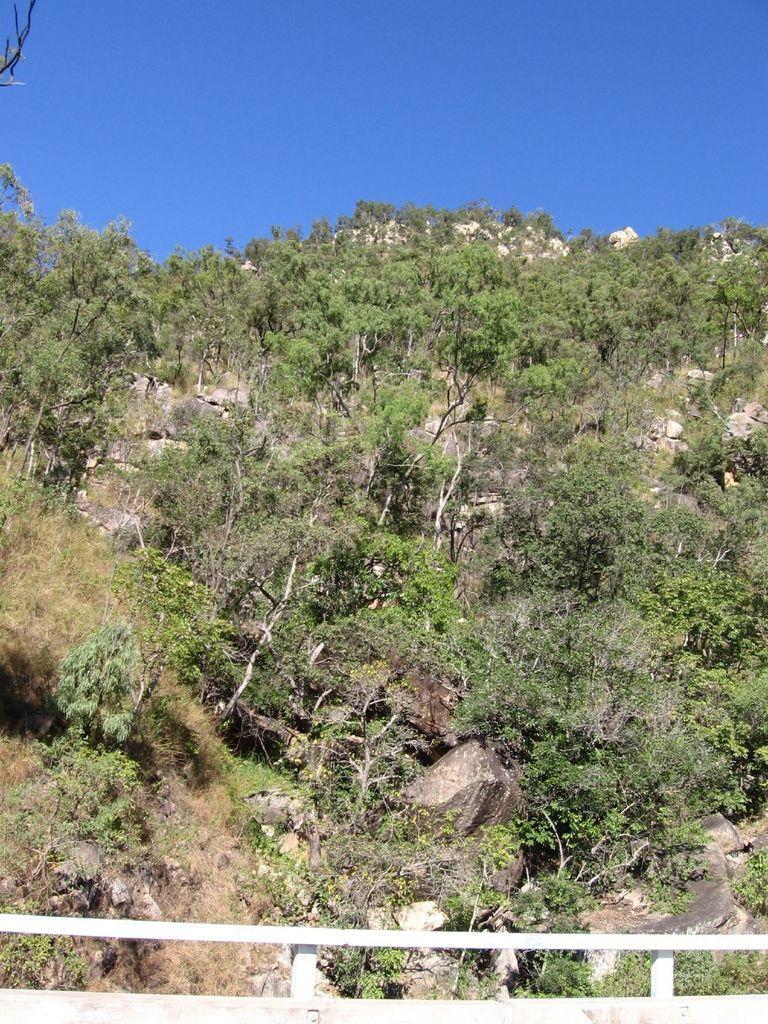In one or two sentences, can you explain what this image depicts? In this picture we can observe some plants and trees. There is a white color railing. In the background there is hill and sky. 